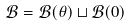<formula> <loc_0><loc_0><loc_500><loc_500>\mathcal { B } = \mathcal { B } ( \theta ) \sqcup \mathcal { B } ( 0 )</formula> 